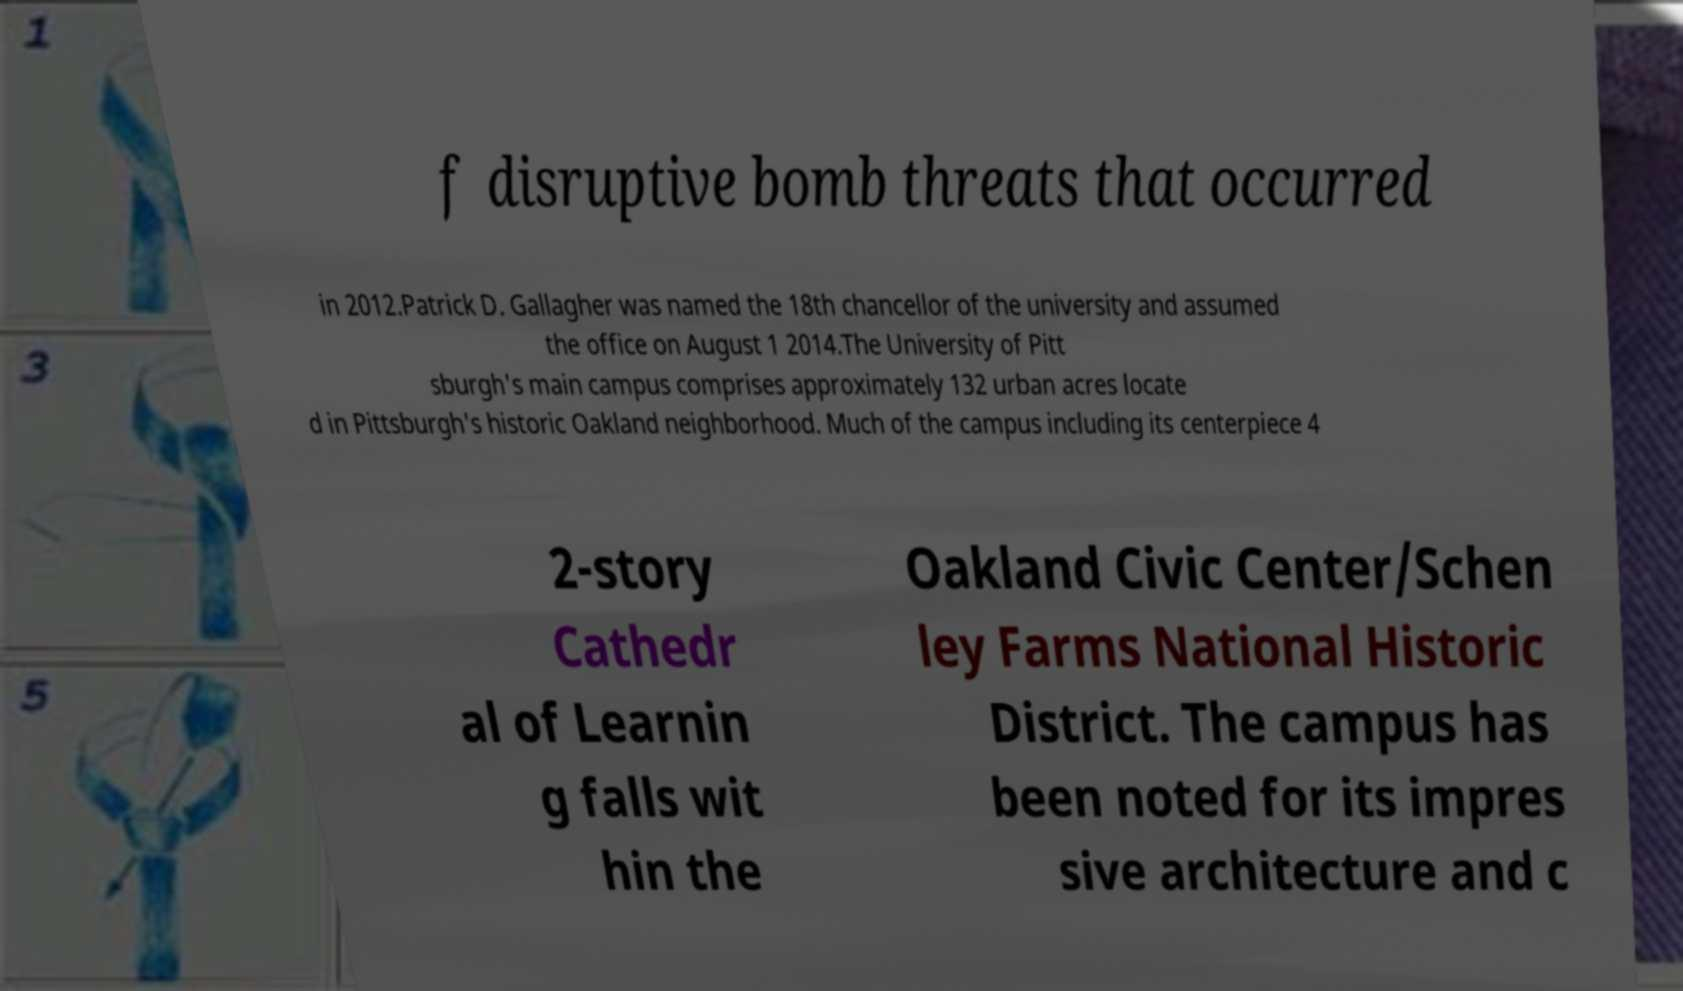I need the written content from this picture converted into text. Can you do that? f disruptive bomb threats that occurred in 2012.Patrick D. Gallagher was named the 18th chancellor of the university and assumed the office on August 1 2014.The University of Pitt sburgh's main campus comprises approximately 132 urban acres locate d in Pittsburgh's historic Oakland neighborhood. Much of the campus including its centerpiece 4 2-story Cathedr al of Learnin g falls wit hin the Oakland Civic Center/Schen ley Farms National Historic District. The campus has been noted for its impres sive architecture and c 